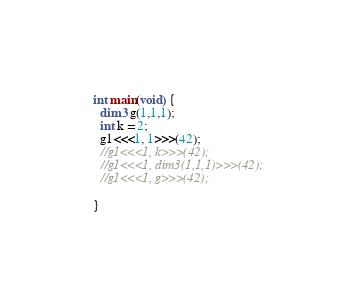<code> <loc_0><loc_0><loc_500><loc_500><_Cuda_>
int main(void) {
  dim3 g(1,1,1);
  int k = 2;
  g1<<<1, 1>>>(42);
  //g1<<<1, k>>>(42);
  //g1<<<1, dim3(1,1,1)>>>(42);
  //g1<<<1, g>>>(42);

}

</code> 